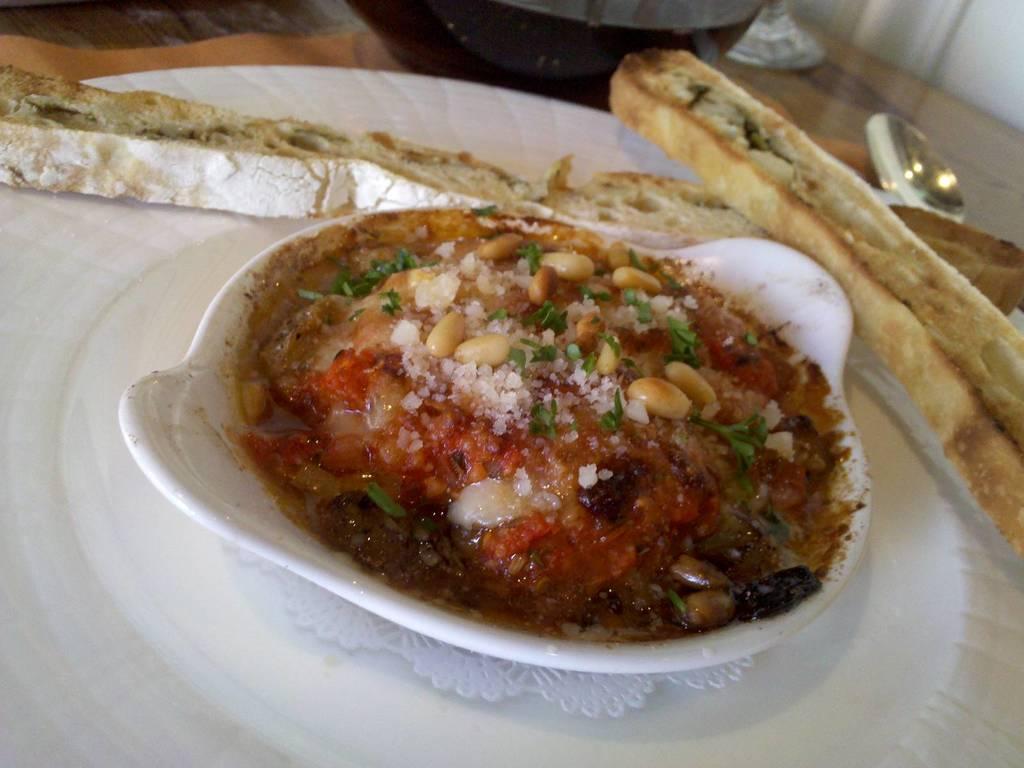Please provide a concise description of this image. In this picture we can see a tray on a wooden surface. There is a mat visible on the tray. We can see some food items in a bowl. This bowl is visible on the mat. We can see some objects on top of the picture. 